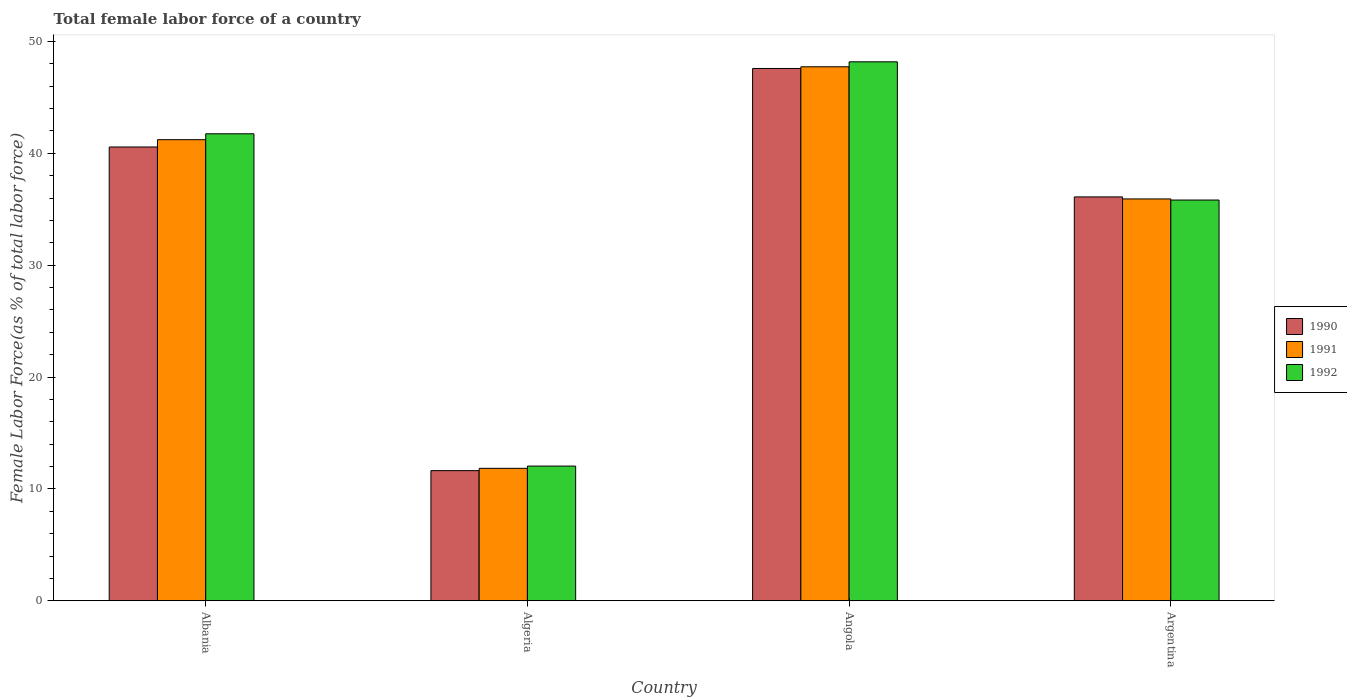How many different coloured bars are there?
Your answer should be very brief. 3. How many groups of bars are there?
Your answer should be compact. 4. How many bars are there on the 4th tick from the right?
Make the answer very short. 3. What is the label of the 1st group of bars from the left?
Keep it short and to the point. Albania. What is the percentage of female labor force in 1992 in Algeria?
Ensure brevity in your answer.  12.04. Across all countries, what is the maximum percentage of female labor force in 1990?
Give a very brief answer. 47.58. Across all countries, what is the minimum percentage of female labor force in 1991?
Provide a succinct answer. 11.84. In which country was the percentage of female labor force in 1991 maximum?
Provide a succinct answer. Angola. In which country was the percentage of female labor force in 1991 minimum?
Offer a very short reply. Algeria. What is the total percentage of female labor force in 1990 in the graph?
Make the answer very short. 135.87. What is the difference between the percentage of female labor force in 1990 in Algeria and that in Angola?
Your answer should be very brief. -35.95. What is the difference between the percentage of female labor force in 1990 in Angola and the percentage of female labor force in 1992 in Albania?
Make the answer very short. 5.84. What is the average percentage of female labor force in 1990 per country?
Ensure brevity in your answer.  33.97. What is the difference between the percentage of female labor force of/in 1991 and percentage of female labor force of/in 1990 in Angola?
Keep it short and to the point. 0.15. In how many countries, is the percentage of female labor force in 1992 greater than 28 %?
Offer a terse response. 3. What is the ratio of the percentage of female labor force in 1991 in Albania to that in Argentina?
Your answer should be compact. 1.15. Is the difference between the percentage of female labor force in 1991 in Angola and Argentina greater than the difference between the percentage of female labor force in 1990 in Angola and Argentina?
Offer a terse response. Yes. What is the difference between the highest and the second highest percentage of female labor force in 1992?
Your answer should be compact. 6.43. What is the difference between the highest and the lowest percentage of female labor force in 1992?
Give a very brief answer. 36.13. Is it the case that in every country, the sum of the percentage of female labor force in 1991 and percentage of female labor force in 1990 is greater than the percentage of female labor force in 1992?
Offer a very short reply. Yes. Are all the bars in the graph horizontal?
Provide a succinct answer. No. What is the difference between two consecutive major ticks on the Y-axis?
Provide a succinct answer. 10. Does the graph contain grids?
Your response must be concise. No. What is the title of the graph?
Provide a succinct answer. Total female labor force of a country. Does "1985" appear as one of the legend labels in the graph?
Offer a very short reply. No. What is the label or title of the Y-axis?
Provide a short and direct response. Female Labor Force(as % of total labor force). What is the Female Labor Force(as % of total labor force) in 1990 in Albania?
Offer a terse response. 40.56. What is the Female Labor Force(as % of total labor force) in 1991 in Albania?
Give a very brief answer. 41.22. What is the Female Labor Force(as % of total labor force) in 1992 in Albania?
Your answer should be compact. 41.74. What is the Female Labor Force(as % of total labor force) in 1990 in Algeria?
Offer a terse response. 11.63. What is the Female Labor Force(as % of total labor force) in 1991 in Algeria?
Your answer should be very brief. 11.84. What is the Female Labor Force(as % of total labor force) of 1992 in Algeria?
Provide a succinct answer. 12.04. What is the Female Labor Force(as % of total labor force) of 1990 in Angola?
Provide a short and direct response. 47.58. What is the Female Labor Force(as % of total labor force) in 1991 in Angola?
Your response must be concise. 47.73. What is the Female Labor Force(as % of total labor force) in 1992 in Angola?
Offer a very short reply. 48.18. What is the Female Labor Force(as % of total labor force) of 1990 in Argentina?
Your answer should be compact. 36.1. What is the Female Labor Force(as % of total labor force) in 1991 in Argentina?
Give a very brief answer. 35.92. What is the Female Labor Force(as % of total labor force) of 1992 in Argentina?
Your answer should be compact. 35.82. Across all countries, what is the maximum Female Labor Force(as % of total labor force) of 1990?
Provide a short and direct response. 47.58. Across all countries, what is the maximum Female Labor Force(as % of total labor force) in 1991?
Give a very brief answer. 47.73. Across all countries, what is the maximum Female Labor Force(as % of total labor force) of 1992?
Offer a very short reply. 48.18. Across all countries, what is the minimum Female Labor Force(as % of total labor force) of 1990?
Make the answer very short. 11.63. Across all countries, what is the minimum Female Labor Force(as % of total labor force) of 1991?
Provide a succinct answer. 11.84. Across all countries, what is the minimum Female Labor Force(as % of total labor force) in 1992?
Offer a very short reply. 12.04. What is the total Female Labor Force(as % of total labor force) of 1990 in the graph?
Make the answer very short. 135.87. What is the total Female Labor Force(as % of total labor force) of 1991 in the graph?
Your response must be concise. 136.71. What is the total Female Labor Force(as % of total labor force) in 1992 in the graph?
Give a very brief answer. 137.78. What is the difference between the Female Labor Force(as % of total labor force) in 1990 in Albania and that in Algeria?
Provide a short and direct response. 28.93. What is the difference between the Female Labor Force(as % of total labor force) of 1991 in Albania and that in Algeria?
Make the answer very short. 29.38. What is the difference between the Female Labor Force(as % of total labor force) of 1992 in Albania and that in Algeria?
Your response must be concise. 29.7. What is the difference between the Female Labor Force(as % of total labor force) in 1990 in Albania and that in Angola?
Offer a very short reply. -7.02. What is the difference between the Female Labor Force(as % of total labor force) of 1991 in Albania and that in Angola?
Offer a very short reply. -6.51. What is the difference between the Female Labor Force(as % of total labor force) in 1992 in Albania and that in Angola?
Keep it short and to the point. -6.43. What is the difference between the Female Labor Force(as % of total labor force) of 1990 in Albania and that in Argentina?
Provide a succinct answer. 4.46. What is the difference between the Female Labor Force(as % of total labor force) in 1991 in Albania and that in Argentina?
Offer a very short reply. 5.3. What is the difference between the Female Labor Force(as % of total labor force) in 1992 in Albania and that in Argentina?
Offer a very short reply. 5.92. What is the difference between the Female Labor Force(as % of total labor force) in 1990 in Algeria and that in Angola?
Offer a terse response. -35.95. What is the difference between the Female Labor Force(as % of total labor force) in 1991 in Algeria and that in Angola?
Your response must be concise. -35.89. What is the difference between the Female Labor Force(as % of total labor force) in 1992 in Algeria and that in Angola?
Your response must be concise. -36.13. What is the difference between the Female Labor Force(as % of total labor force) in 1990 in Algeria and that in Argentina?
Your answer should be compact. -24.47. What is the difference between the Female Labor Force(as % of total labor force) in 1991 in Algeria and that in Argentina?
Keep it short and to the point. -24.08. What is the difference between the Female Labor Force(as % of total labor force) in 1992 in Algeria and that in Argentina?
Make the answer very short. -23.78. What is the difference between the Female Labor Force(as % of total labor force) in 1990 in Angola and that in Argentina?
Offer a terse response. 11.48. What is the difference between the Female Labor Force(as % of total labor force) in 1991 in Angola and that in Argentina?
Ensure brevity in your answer.  11.81. What is the difference between the Female Labor Force(as % of total labor force) of 1992 in Angola and that in Argentina?
Give a very brief answer. 12.35. What is the difference between the Female Labor Force(as % of total labor force) of 1990 in Albania and the Female Labor Force(as % of total labor force) of 1991 in Algeria?
Your answer should be compact. 28.72. What is the difference between the Female Labor Force(as % of total labor force) in 1990 in Albania and the Female Labor Force(as % of total labor force) in 1992 in Algeria?
Give a very brief answer. 28.52. What is the difference between the Female Labor Force(as % of total labor force) of 1991 in Albania and the Female Labor Force(as % of total labor force) of 1992 in Algeria?
Give a very brief answer. 29.17. What is the difference between the Female Labor Force(as % of total labor force) of 1990 in Albania and the Female Labor Force(as % of total labor force) of 1991 in Angola?
Your response must be concise. -7.17. What is the difference between the Female Labor Force(as % of total labor force) in 1990 in Albania and the Female Labor Force(as % of total labor force) in 1992 in Angola?
Your answer should be compact. -7.61. What is the difference between the Female Labor Force(as % of total labor force) in 1991 in Albania and the Female Labor Force(as % of total labor force) in 1992 in Angola?
Provide a succinct answer. -6.96. What is the difference between the Female Labor Force(as % of total labor force) of 1990 in Albania and the Female Labor Force(as % of total labor force) of 1991 in Argentina?
Offer a very short reply. 4.64. What is the difference between the Female Labor Force(as % of total labor force) of 1990 in Albania and the Female Labor Force(as % of total labor force) of 1992 in Argentina?
Provide a short and direct response. 4.74. What is the difference between the Female Labor Force(as % of total labor force) of 1991 in Albania and the Female Labor Force(as % of total labor force) of 1992 in Argentina?
Ensure brevity in your answer.  5.39. What is the difference between the Female Labor Force(as % of total labor force) of 1990 in Algeria and the Female Labor Force(as % of total labor force) of 1991 in Angola?
Provide a succinct answer. -36.1. What is the difference between the Female Labor Force(as % of total labor force) of 1990 in Algeria and the Female Labor Force(as % of total labor force) of 1992 in Angola?
Your answer should be very brief. -36.54. What is the difference between the Female Labor Force(as % of total labor force) of 1991 in Algeria and the Female Labor Force(as % of total labor force) of 1992 in Angola?
Provide a succinct answer. -36.34. What is the difference between the Female Labor Force(as % of total labor force) in 1990 in Algeria and the Female Labor Force(as % of total labor force) in 1991 in Argentina?
Ensure brevity in your answer.  -24.29. What is the difference between the Female Labor Force(as % of total labor force) in 1990 in Algeria and the Female Labor Force(as % of total labor force) in 1992 in Argentina?
Provide a succinct answer. -24.19. What is the difference between the Female Labor Force(as % of total labor force) of 1991 in Algeria and the Female Labor Force(as % of total labor force) of 1992 in Argentina?
Provide a short and direct response. -23.98. What is the difference between the Female Labor Force(as % of total labor force) in 1990 in Angola and the Female Labor Force(as % of total labor force) in 1991 in Argentina?
Provide a succinct answer. 11.66. What is the difference between the Female Labor Force(as % of total labor force) of 1990 in Angola and the Female Labor Force(as % of total labor force) of 1992 in Argentina?
Make the answer very short. 11.76. What is the difference between the Female Labor Force(as % of total labor force) in 1991 in Angola and the Female Labor Force(as % of total labor force) in 1992 in Argentina?
Offer a terse response. 11.91. What is the average Female Labor Force(as % of total labor force) of 1990 per country?
Make the answer very short. 33.97. What is the average Female Labor Force(as % of total labor force) of 1991 per country?
Keep it short and to the point. 34.18. What is the average Female Labor Force(as % of total labor force) in 1992 per country?
Offer a terse response. 34.45. What is the difference between the Female Labor Force(as % of total labor force) in 1990 and Female Labor Force(as % of total labor force) in 1991 in Albania?
Offer a very short reply. -0.65. What is the difference between the Female Labor Force(as % of total labor force) of 1990 and Female Labor Force(as % of total labor force) of 1992 in Albania?
Make the answer very short. -1.18. What is the difference between the Female Labor Force(as % of total labor force) of 1991 and Female Labor Force(as % of total labor force) of 1992 in Albania?
Your answer should be compact. -0.53. What is the difference between the Female Labor Force(as % of total labor force) of 1990 and Female Labor Force(as % of total labor force) of 1991 in Algeria?
Your answer should be compact. -0.21. What is the difference between the Female Labor Force(as % of total labor force) of 1990 and Female Labor Force(as % of total labor force) of 1992 in Algeria?
Provide a short and direct response. -0.41. What is the difference between the Female Labor Force(as % of total labor force) of 1991 and Female Labor Force(as % of total labor force) of 1992 in Algeria?
Give a very brief answer. -0.2. What is the difference between the Female Labor Force(as % of total labor force) of 1990 and Female Labor Force(as % of total labor force) of 1991 in Angola?
Your answer should be compact. -0.15. What is the difference between the Female Labor Force(as % of total labor force) in 1990 and Female Labor Force(as % of total labor force) in 1992 in Angola?
Your answer should be very brief. -0.59. What is the difference between the Female Labor Force(as % of total labor force) of 1991 and Female Labor Force(as % of total labor force) of 1992 in Angola?
Provide a short and direct response. -0.44. What is the difference between the Female Labor Force(as % of total labor force) of 1990 and Female Labor Force(as % of total labor force) of 1991 in Argentina?
Ensure brevity in your answer.  0.18. What is the difference between the Female Labor Force(as % of total labor force) in 1990 and Female Labor Force(as % of total labor force) in 1992 in Argentina?
Provide a short and direct response. 0.28. What is the difference between the Female Labor Force(as % of total labor force) of 1991 and Female Labor Force(as % of total labor force) of 1992 in Argentina?
Give a very brief answer. 0.1. What is the ratio of the Female Labor Force(as % of total labor force) of 1990 in Albania to that in Algeria?
Your answer should be very brief. 3.49. What is the ratio of the Female Labor Force(as % of total labor force) of 1991 in Albania to that in Algeria?
Provide a short and direct response. 3.48. What is the ratio of the Female Labor Force(as % of total labor force) of 1992 in Albania to that in Algeria?
Your answer should be compact. 3.47. What is the ratio of the Female Labor Force(as % of total labor force) of 1990 in Albania to that in Angola?
Provide a short and direct response. 0.85. What is the ratio of the Female Labor Force(as % of total labor force) in 1991 in Albania to that in Angola?
Keep it short and to the point. 0.86. What is the ratio of the Female Labor Force(as % of total labor force) in 1992 in Albania to that in Angola?
Offer a terse response. 0.87. What is the ratio of the Female Labor Force(as % of total labor force) in 1990 in Albania to that in Argentina?
Provide a succinct answer. 1.12. What is the ratio of the Female Labor Force(as % of total labor force) of 1991 in Albania to that in Argentina?
Give a very brief answer. 1.15. What is the ratio of the Female Labor Force(as % of total labor force) in 1992 in Albania to that in Argentina?
Make the answer very short. 1.17. What is the ratio of the Female Labor Force(as % of total labor force) in 1990 in Algeria to that in Angola?
Ensure brevity in your answer.  0.24. What is the ratio of the Female Labor Force(as % of total labor force) of 1991 in Algeria to that in Angola?
Keep it short and to the point. 0.25. What is the ratio of the Female Labor Force(as % of total labor force) in 1992 in Algeria to that in Angola?
Your answer should be compact. 0.25. What is the ratio of the Female Labor Force(as % of total labor force) in 1990 in Algeria to that in Argentina?
Ensure brevity in your answer.  0.32. What is the ratio of the Female Labor Force(as % of total labor force) of 1991 in Algeria to that in Argentina?
Give a very brief answer. 0.33. What is the ratio of the Female Labor Force(as % of total labor force) of 1992 in Algeria to that in Argentina?
Your answer should be compact. 0.34. What is the ratio of the Female Labor Force(as % of total labor force) in 1990 in Angola to that in Argentina?
Ensure brevity in your answer.  1.32. What is the ratio of the Female Labor Force(as % of total labor force) of 1991 in Angola to that in Argentina?
Make the answer very short. 1.33. What is the ratio of the Female Labor Force(as % of total labor force) of 1992 in Angola to that in Argentina?
Make the answer very short. 1.34. What is the difference between the highest and the second highest Female Labor Force(as % of total labor force) of 1990?
Your response must be concise. 7.02. What is the difference between the highest and the second highest Female Labor Force(as % of total labor force) in 1991?
Make the answer very short. 6.51. What is the difference between the highest and the second highest Female Labor Force(as % of total labor force) in 1992?
Your answer should be compact. 6.43. What is the difference between the highest and the lowest Female Labor Force(as % of total labor force) of 1990?
Make the answer very short. 35.95. What is the difference between the highest and the lowest Female Labor Force(as % of total labor force) of 1991?
Your response must be concise. 35.89. What is the difference between the highest and the lowest Female Labor Force(as % of total labor force) of 1992?
Provide a short and direct response. 36.13. 